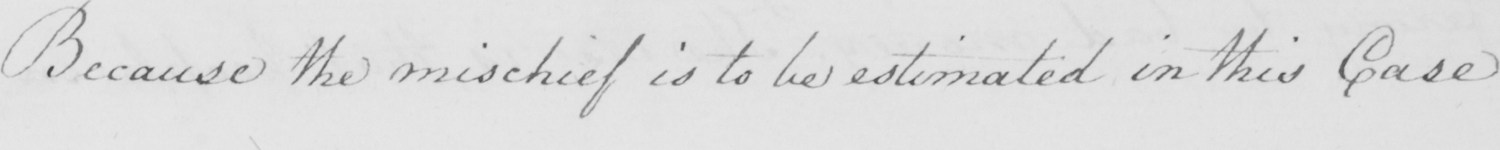Can you tell me what this handwritten text says? Because the mischief is to be estimated in this Case 